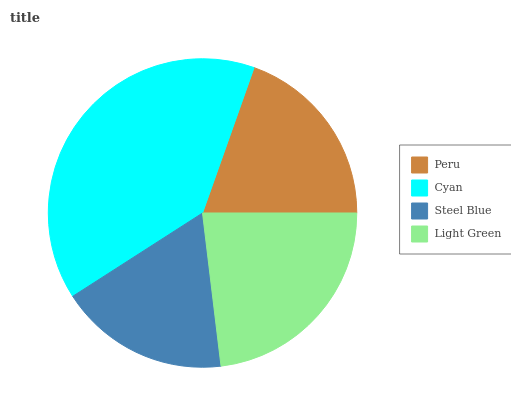Is Steel Blue the minimum?
Answer yes or no. Yes. Is Cyan the maximum?
Answer yes or no. Yes. Is Cyan the minimum?
Answer yes or no. No. Is Steel Blue the maximum?
Answer yes or no. No. Is Cyan greater than Steel Blue?
Answer yes or no. Yes. Is Steel Blue less than Cyan?
Answer yes or no. Yes. Is Steel Blue greater than Cyan?
Answer yes or no. No. Is Cyan less than Steel Blue?
Answer yes or no. No. Is Light Green the high median?
Answer yes or no. Yes. Is Peru the low median?
Answer yes or no. Yes. Is Cyan the high median?
Answer yes or no. No. Is Light Green the low median?
Answer yes or no. No. 